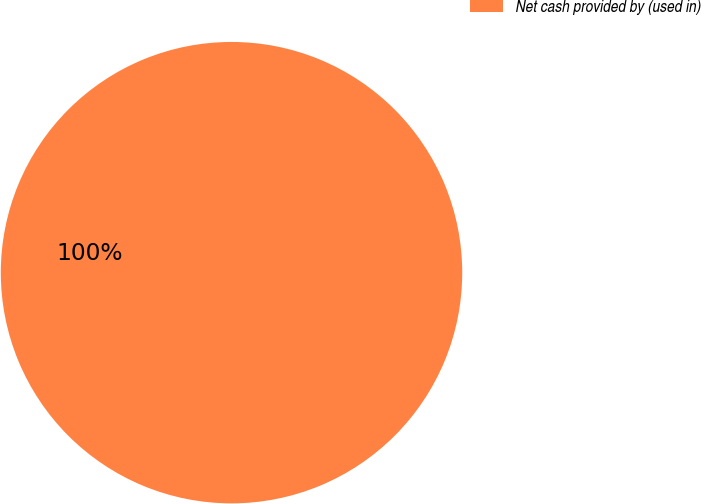Convert chart to OTSL. <chart><loc_0><loc_0><loc_500><loc_500><pie_chart><fcel>Net cash provided by (used in)<nl><fcel>100.0%<nl></chart> 